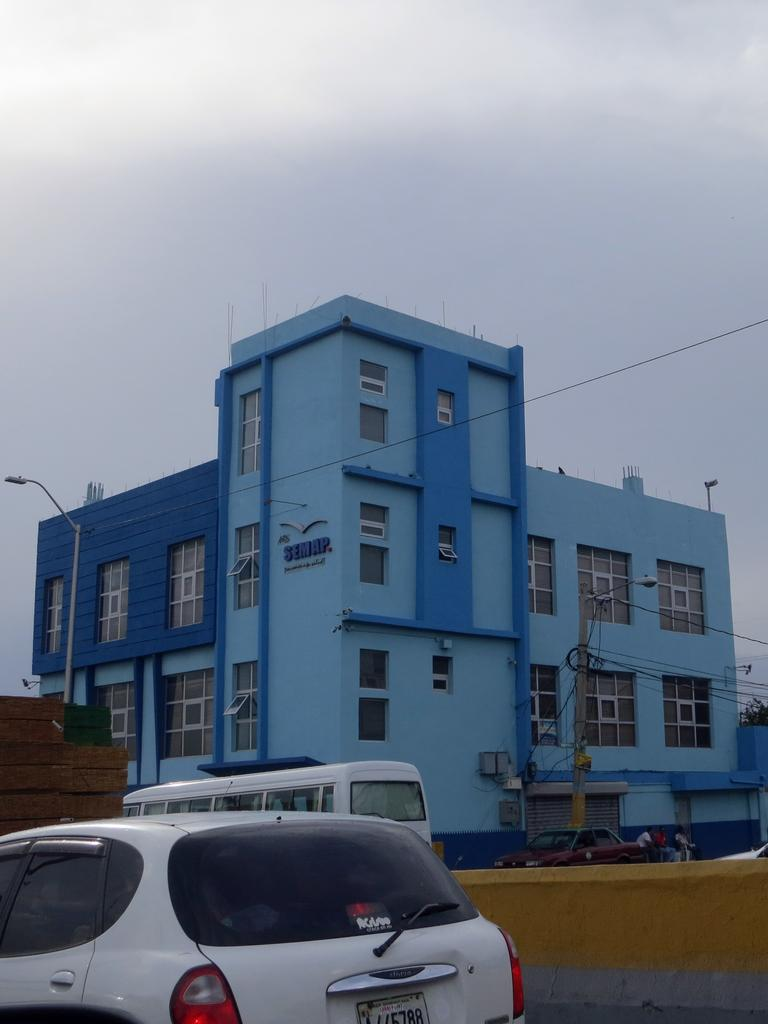What is the main structure in the center of the image? There is a building in the center of the image. What types of vehicles can be seen at the bottom of the image? Cars and a bus are visible at the bottom of the image. What are the tall, thin objects in the image? There are poles in the image. What is visible in the top part of the image? The sky is visible at the top of the image. What type of meal is being prepared in the image? There is no meal preparation visible in the image. What is the cent of the image? The term "cent" is not applicable to describing the image, as it refers to a unit of currency or a central point, neither of which is relevant to the image. 